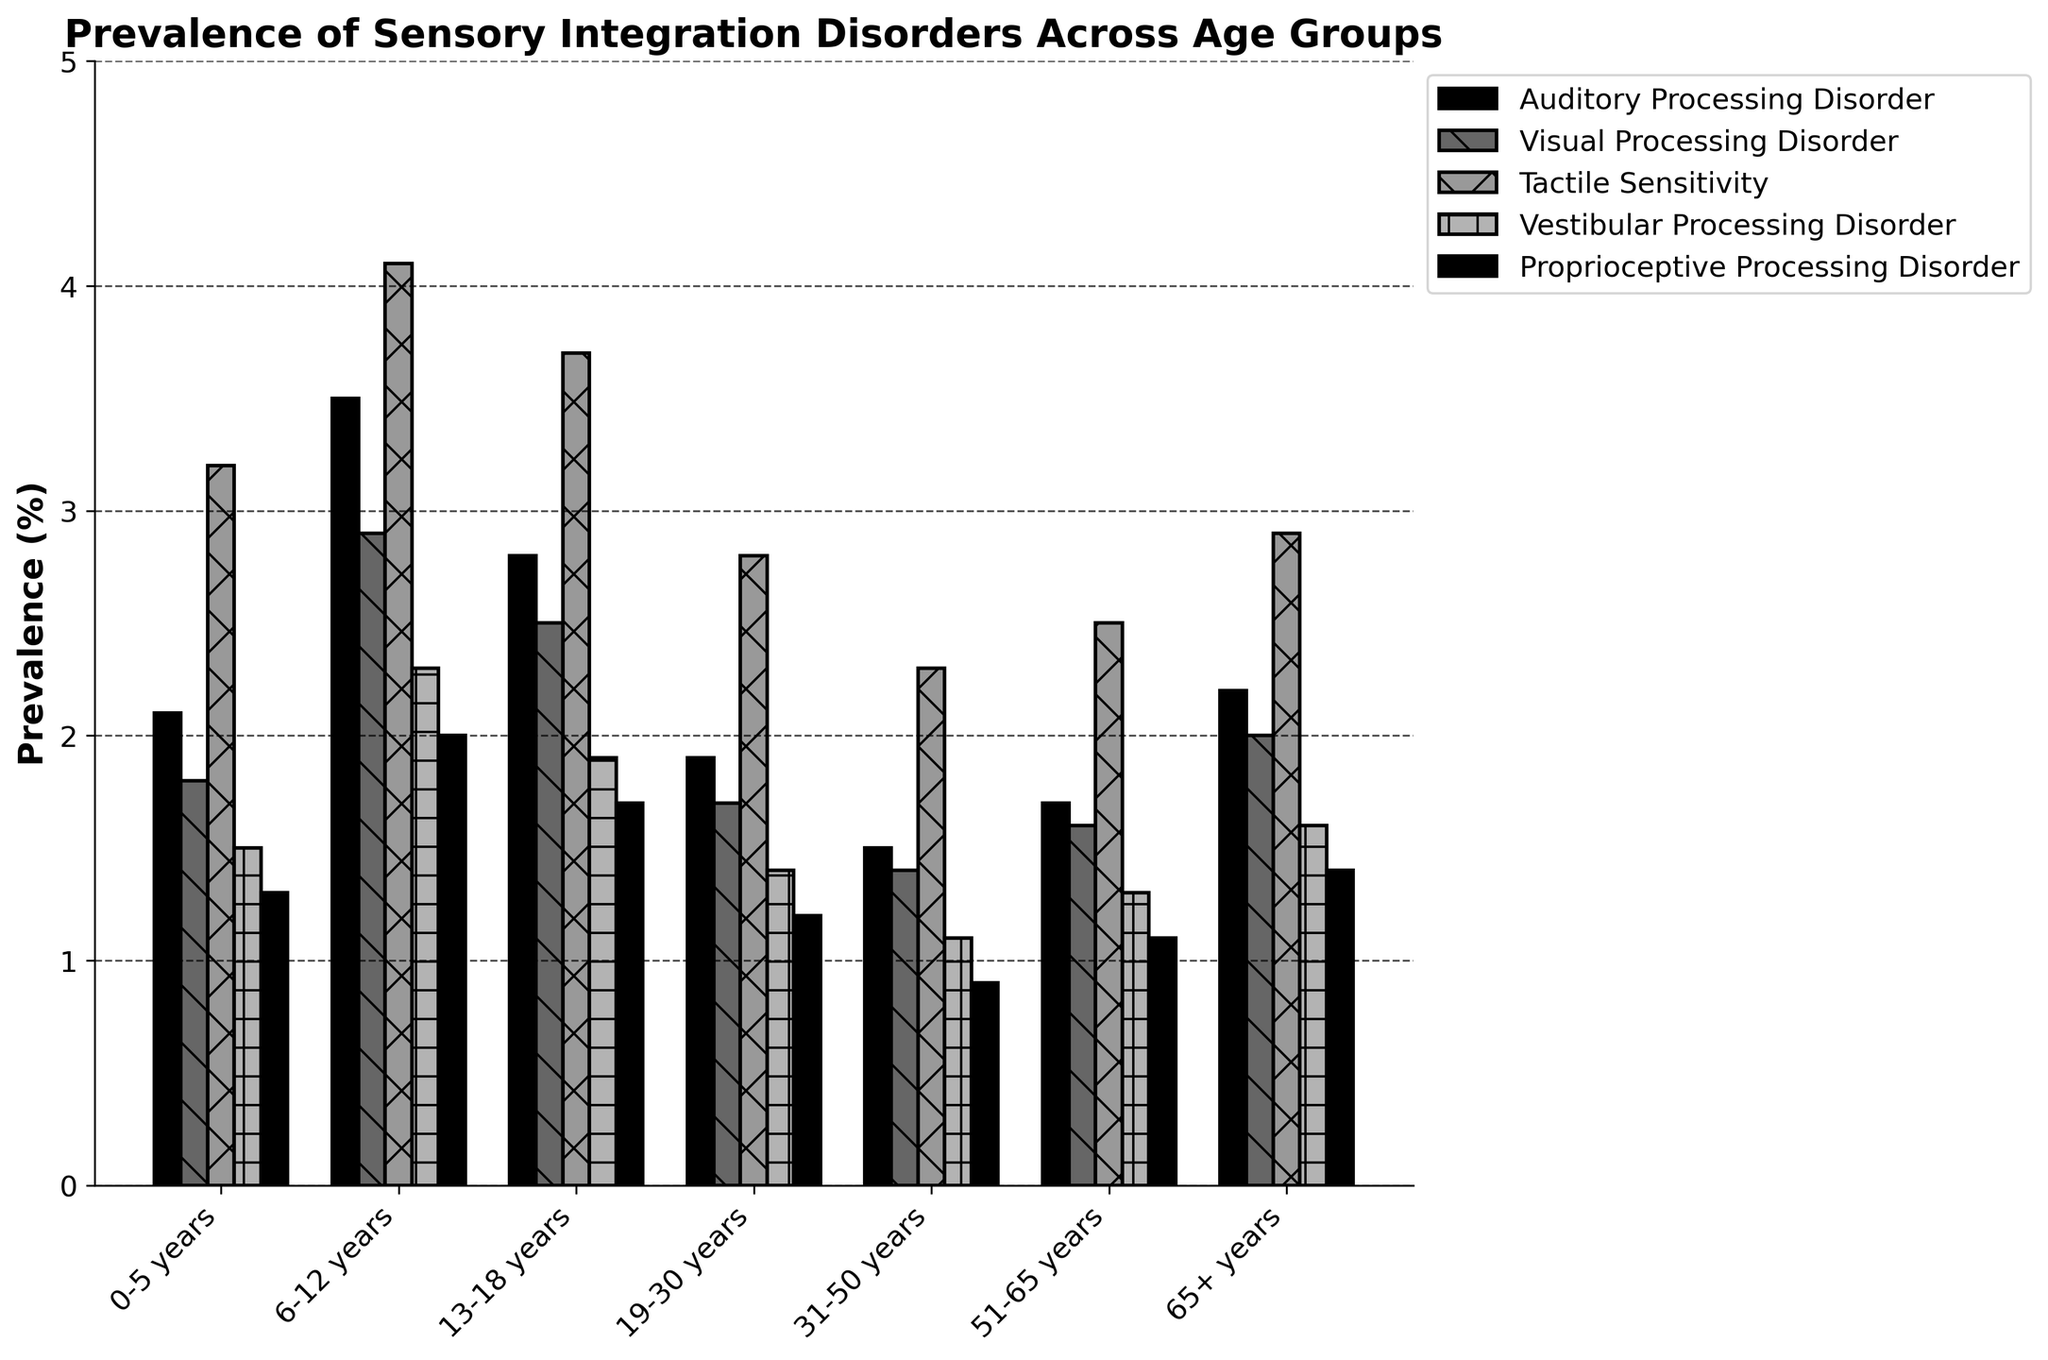What's the most prevalent sensory integration disorder in the 6-12 years age group? To find the most prevalent disorder for the 6-12 years age group, we need to compare the values of all disorders for this age group. Auditory Processing Disorder is 3.5%, Visual Processing Disorder is 2.9%, Tactile Sensitivity is 4.1%, Vestibular Processing Disorder is 2.3%, and Proprioceptive Processing Disorder is 2.0%. The highest value is 4.1%, corresponding to Tactile Sensitivity.
Answer: Tactile Sensitivity Which age group shows the least prevalence of Visual Processing Disorder? To determine which age group has the least Visual Processing Disorder prevalence, compare all age groups' values. The values are: 1.8% (0-5 years), 2.9% (6-12 years), 2.5% (13-18 years), 1.7% (19-30 years), 1.4% (31-50 years), 1.6% (51-65 years), and 2.0% (65+ years). The lowest value is 1.4%, corresponding to the 31-50 years age group.
Answer: 31-50 years How does the prevalence of Auditory Processing Disorder in the 19-30 years group compare to the 65+ years group? The prevalence of Auditory Processing Disorder is 1.9% in the 19-30 years group and 2.2% in the 65+ years group. By comparing the two, we see that 2.2% (65+ years) is greater than 1.9% (19-30 years).
Answer: 2.2% is greater What is the combined total prevalence of all disorders in the 0-5 years age group? Sum the prevalence values of all disorders for the 0-5 years age group: 2.1% (Auditory Processing Disorder) + 1.8% (Visual Processing Disorder) + 3.2% (Tactile Sensitivity) + 1.5% (Vestibular Processing Disorder) + 1.3% (Proprioceptive Processing Disorder). The total is 2.1 + 1.8 + 3.2 + 1.5 + 1.3 = 9.9%.
Answer: 9.9% What is the average prevalence of Tactile Sensitivity across all age groups? To find the average prevalence, sum the Tactile Sensitivity values across all age groups and divide by the number of age groups. The values are: 3.2%, 4.1%, 3.7%, 2.8%, 2.3%, 2.5%, 2.9%. The total is 3.2 + 4.1 + 3.7 + 2.8 + 2.3 + 2.5 + 2.9 = 21.5%. There are 7 age groups, so the average is 21.5 / 7 = 3.07%.
Answer: 3.07% Which disorder has the closest prevalence values across all age groups? Compare the range of prevalence values for each disorder. Auditory Processing Disorder values range from 1.5% to 3.5%, Visual Processing Disorder from 1.4% to 2.9%, Tactile Sensitivity from 2.3% to 4.1%, Vestibular Processing Disorder from 1.1% to 2.3%, and Proprioceptive Processing Disorder from 0.9% to 2.0%. Visual Processing Disorder has the smallest range (1.4% to 2.9%).
Answer: Visual Processing Disorder Which age group shows a higher prevalence of Vestibular Processing Disorder compared to Proprioceptive Processing Disorder? Compare the values of Vestibular and Proprioceptive Processing Disorders within each age group. Identify the groups where Vestibular Processing Disorder is greater than Proprioceptive Processing Disorder: 0-5 years: 1.5 > 1.3, 6-12 years: 2.3 > 2.0, 13-18 years: 1.9 > 1.7, 19-30 years: 1.4 > 1.2, 31-50 years: 1.1 > 0.9, 51-65 years: 1.3 > 1.1, 65+ years: 1.6 > 1.4. All age groups show this pattern.
Answer: All age groups What is the difference in the prevalence of Tactile Sensitivity between the 13-18 years group and the 51-65 years group? Subtract the prevalence value of Tactile Sensitivity in the 51-65 years group from that in the 13-18 years group: 3.7% (13-18 years) - 2.5% (51-65 years). The difference is 3.7 - 2.5 = 1.2%.
Answer: 1.2% How does the prevalence of Vestibular Processing Disorder change from the 0-5 years group to the 6-12 years group? Subtract the prevalence value of Vestibular Processing Disorder in the 0-5 years group from that in the 6-12 years group: 2.3% (6-12 years) - 1.5% (0-5 years). The change is 2.3 - 1.5 = 0.8%.
Answer: Increases by 0.8% Which two age groups have the smallest difference in the prevalence of Proprioceptive Processing Disorder? Calculate the difference in Proprioceptive Processing Disorder prevalence between each pair of age groups and identify the smallest difference. The differences are: 0-5 vs 6-12 years: 0.7, 0-5 vs 13-18 years: 0.4, 0-5 vs 19-30 years: 0.1, 0-5 vs 31-50 years: 0.4, 0-5 vs 51-65 years: 0.2, 0-5 vs 65+ years: 0.1, 6-12 vs 13-18 years: 0.3, 6-12 vs 19-30 years: 0.8, 6-12 vs 31-50 years: 1.1, 6-12 vs 51-65 years: 0.9, 6-12 vs 65+ years: 0.6, 13-18 vs 19-30 years: 0.5, 13-18 vs 31-50 years: 0.8, 13-18 vs 51-65 years: 0.6, 13-18 vs 65+ years: 0.3, 19-30 vs 31-50 years: 0.3, 19-30 vs 51-65 years: 0.1, 19-30 vs 65+ years: 0.2, 31-50 vs 51-65 years: 0.2, 31-50 vs 65+ years: 0.5, 51-65 vs 65+ years: 0.3. The smallest differences are between 0-5 years vs 19-30 years and 6-65 years vs 19-30 years, both at 0.1%.
Answer: 0-5 and 19-30 years; 65+ and 19-30 years 